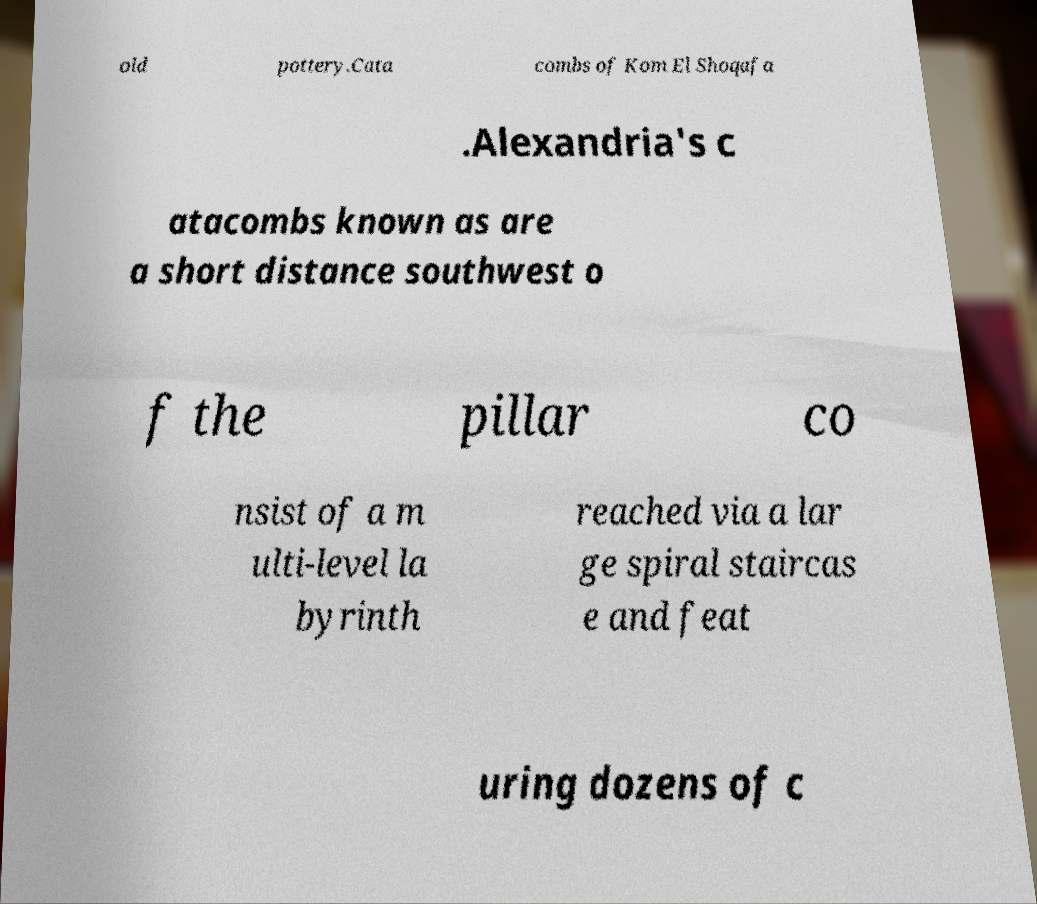Can you read and provide the text displayed in the image?This photo seems to have some interesting text. Can you extract and type it out for me? old pottery.Cata combs of Kom El Shoqafa .Alexandria's c atacombs known as are a short distance southwest o f the pillar co nsist of a m ulti-level la byrinth reached via a lar ge spiral staircas e and feat uring dozens of c 